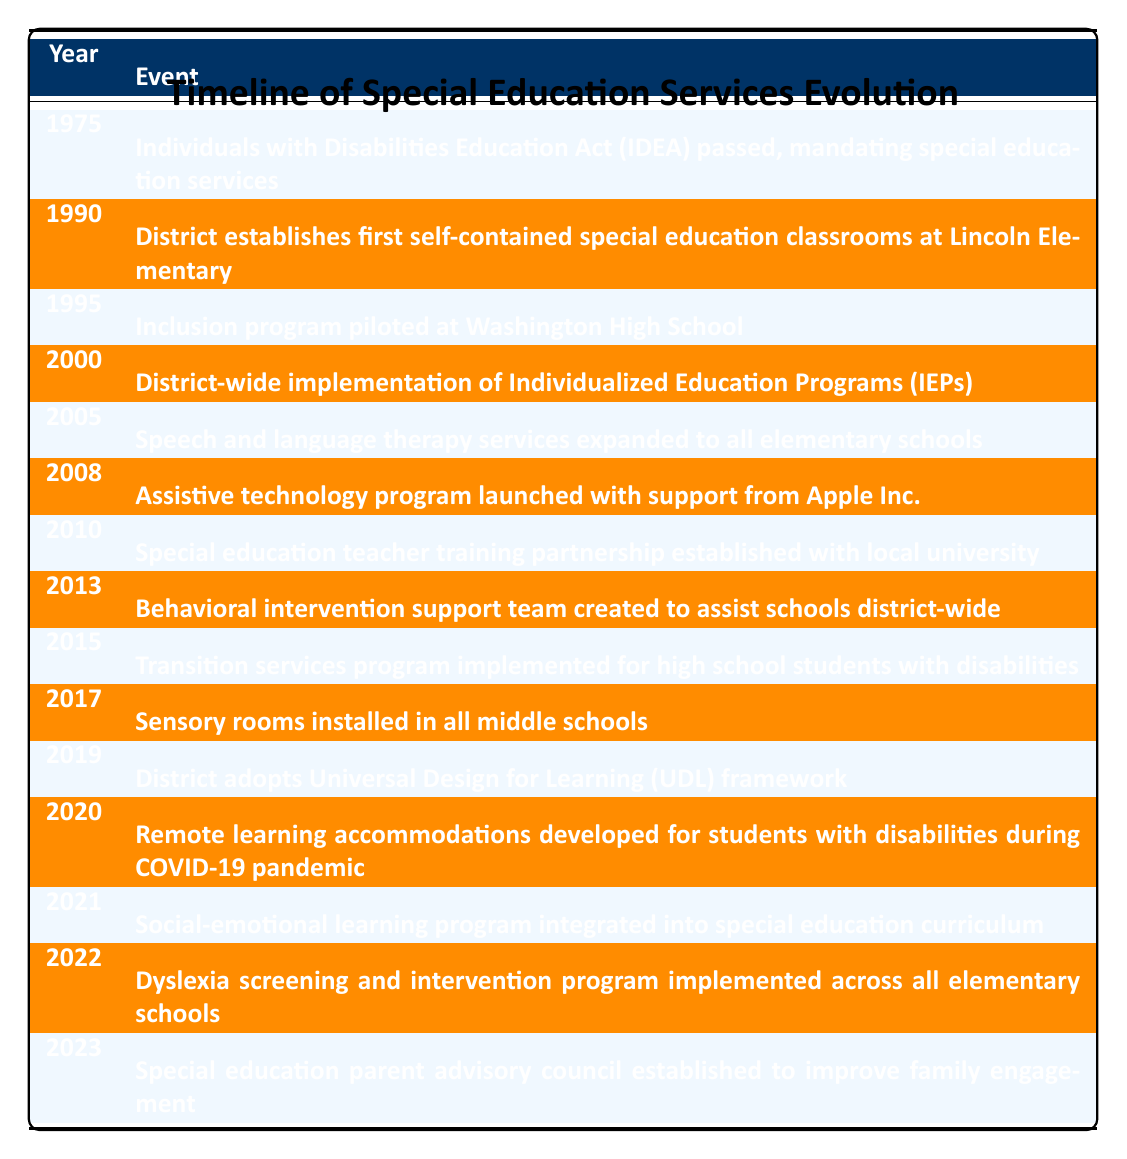What year was the Individuals with Disabilities Education Act (IDEA) passed? The table clearly states that the event "Individuals with Disabilities Education Act (IDEA) passed, mandating special education services" occurred in 1975.
Answer: 1975 In what year did the district establish self-contained special education classrooms? Referring to the table, the event "District establishes first self-contained special education classrooms at Lincoln Elementary" is listed for the year 1990.
Answer: 1990 Was the Assistive Technology Program launched before or after 2005? The event "Assistive technology program launched with support from Apple Inc." is marked under the year 2008, which is after the year 2005.
Answer: After How many years were there between the launch of the Universal Design for Learning (UDL) framework and the establishment of the Special Education Parent Advisory Council? The UDL framework was adopted in 2019 and the parent advisory council was established in 2023. The difference in years is 2023 - 2019 = 4 years.
Answer: 4 years Did the district implement transition services before or after they installed sensory rooms in middle schools? The table shows that the transition services program was implemented in 2015, while sensory rooms were installed in 2017, indicating that transition services were implemented before sensory rooms.
Answer: Before How many total major events occurred in the evolution of special education services and support from 1975 to 2023? The table lists a total of 15 separate events relating to the evolution of special education services between the years 1975 and 2023.
Answer: 15 What specific program was added to support students with disabilities during the COVID-19 pandemic? According to the table, the event "Remote learning accommodations developed for students with disabilities during COVID-19 pandemic" clearly indicates the specific program added during that time.
Answer: Remote learning accommodations In which year was the first inclusion program piloted, and what was its location? The table specifies that the first inclusion program was piloted in 1995 at Washington High School.
Answer: 1995 at Washington High School What is the average year of the events listed in the timeline? To find the average, first, we add all the years (1975 + 1990 + 1995 + 2000 + 2005 + 2008 + 2010 + 2013 + 2015 + 2017 + 2019 + 2020 + 2021 + 2022 + 2023 = 29968). There are 15 events, so the average is 29968 / 15 = 1998.53, rounded down gives 1998.
Answer: 1998 